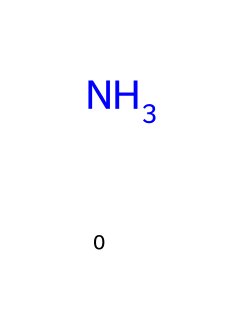How many hydrogen atoms are in ammonia? The SMILES representation shows one nitrogen atom (N) bound to three hydrogen atoms (implied by the typical structure of ammonia), which means there are a total of three hydrogen atoms.
Answer: three What is the molecular type of ammonia? Ammonia has a distinct structure characterized by its nitrogen and hydrogen composition, classifying it as an amine, specifically a primary amine, due to the presence of one nitrogen atom bonded to hydrogens.
Answer: amine What is the number of bonds in ammonia? Ammonia consists of one nitrogen atom bonded to three hydrogen atoms, leading to a total of three covalent bonds within the molecule.
Answer: three Is ammonia a natural refrigerant? Ammonia is widely recognized as a natural refrigerant in vintage ice-making machines, noted for its effectiveness and relatively low environmental impact, particularly compared to synthetic refrigerants.
Answer: yes How does ammonia help in refrigeration? The structure of ammonia allows it to undergo phase changes efficiently, absorbing heat from its environment when evaporating in refrigeration systems, making it an effective refrigerant.
Answer: by absorbing heat What is the boiling point of ammonia? The boiling point of ammonia is approximately -33.3 degrees Celsius under standard atmospheric conditions, making it effective in refrigeration applications, especially in vintage machines.
Answer: -33.3 degrees Celsius 